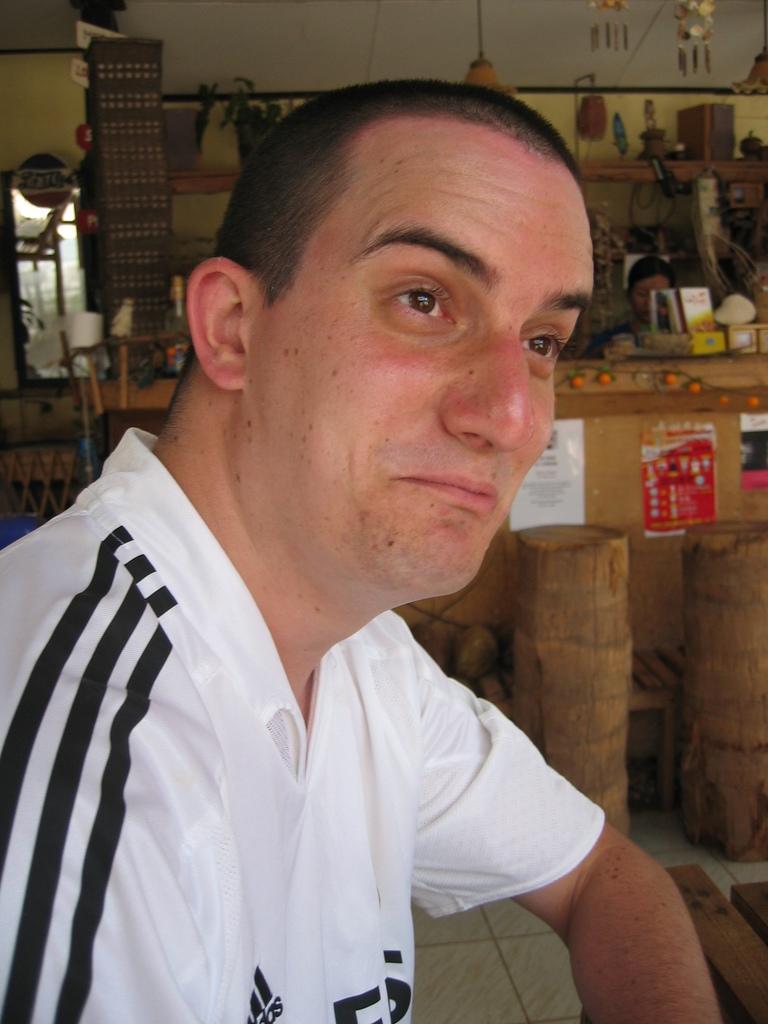Could you give a brief overview of what you see in this image? In this image I can see a man wearing a white color t-shirt and background I can see the wall and some objects kept in front of the wall and wooden tables kept in front of the wall. 